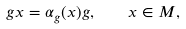Convert formula to latex. <formula><loc_0><loc_0><loc_500><loc_500>g x = \alpha _ { g } ( x ) g , \quad x \in M ,</formula> 